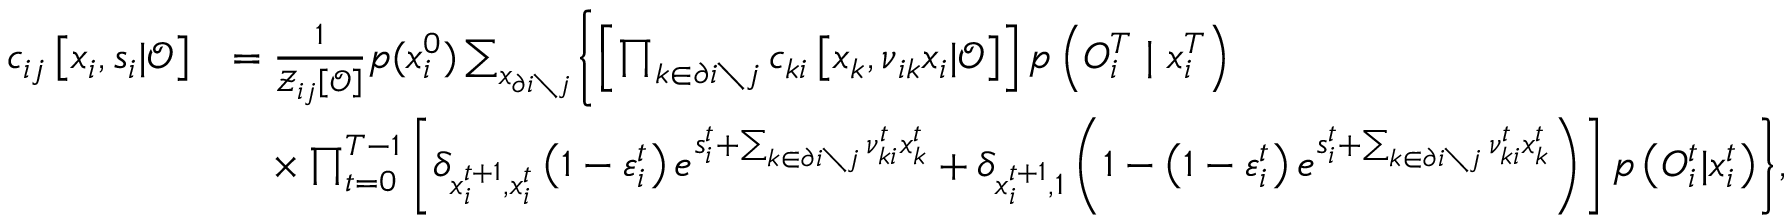<formula> <loc_0><loc_0><loc_500><loc_500>\begin{array} { r l } { c _ { i j } \left [ x _ { i } , s _ { i } | \mathcal { O } \right ] } & { = \frac { 1 } { \mathcal { Z } _ { i j } \left [ \mathcal { O } \right ] } p ( x _ { i } ^ { 0 } ) \sum _ { x _ { \partial i \ j } } \left \{ \left [ \prod _ { k \in \partial i \ j } c _ { k i } \left [ x _ { k } , \nu _ { i k } x _ { i } | \mathcal { O } \right ] \right ] p \left ( { O } _ { i } ^ { T } | x _ { i } ^ { T } \right ) } \\ & { \quad \times \prod _ { t = 0 } ^ { T - 1 } \left [ \delta _ { x _ { i } ^ { t + 1 } , x _ { i } ^ { t } } \left ( 1 - \varepsilon _ { i } ^ { t } \right ) e ^ { s _ { i } ^ { t } + \sum _ { k \in \partial i \ j } \nu _ { k i } ^ { t } x _ { k } ^ { t } } + \delta _ { x _ { i } ^ { t + 1 } , 1 } \left ( 1 - \left ( 1 - \varepsilon _ { i } ^ { t } \right ) e ^ { s _ { i } ^ { t } + \sum _ { k \in \partial i \ j } \nu _ { k i } ^ { t } x _ { k } ^ { t } } \right ) \right ] p \left ( { O } _ { i } ^ { t } | x _ { i } ^ { t } \right ) \right \} , } \end{array}</formula> 